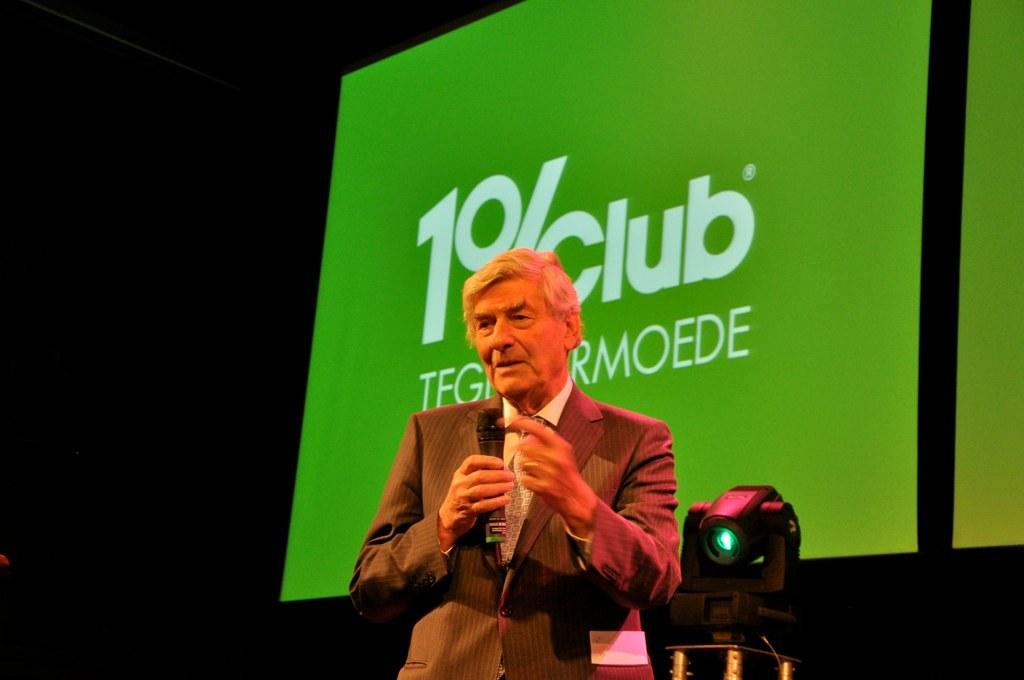What is the main subject of the image? The main subject of the image is a man standing in the middle. What is the man holding in the image? The man is holding a microphone. Can you describe the object beside the man? There is a black color object beside the man. What can be seen in the background of the image? A: There is a projector screen in the background of the image. What type of fish can be seen swimming in the garden in the image? There is no garden or fish present in the image. 